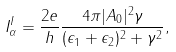<formula> <loc_0><loc_0><loc_500><loc_500>I _ { \alpha } ^ { I } = \frac { 2 e } { h } \frac { 4 \pi | A _ { 0 } | ^ { 2 } \gamma } { ( \epsilon _ { 1 } + \epsilon _ { 2 } ) ^ { 2 } + \gamma ^ { 2 } } ,</formula> 